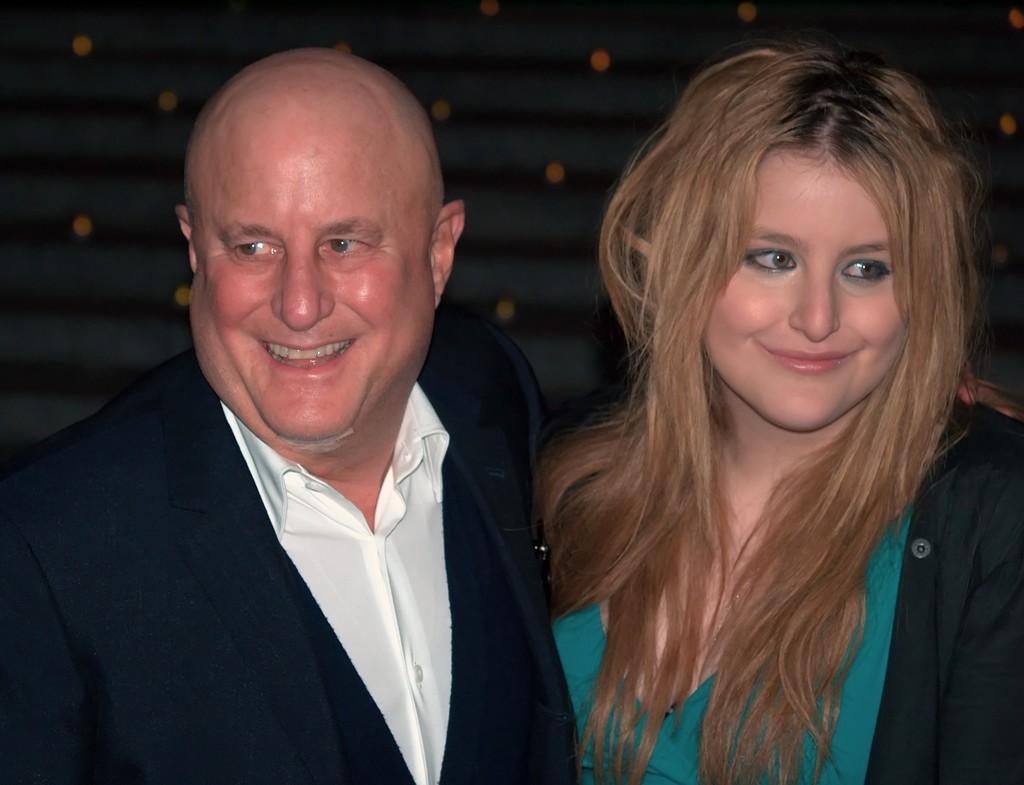Could you give a brief overview of what you see in this image? In this image in the front there are persons smiling and the background is blurry. 